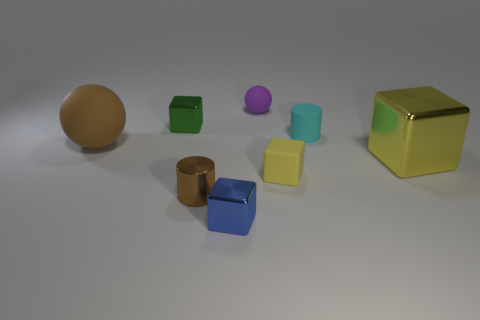Subtract all yellow metal cubes. How many cubes are left? 3 Add 2 large purple rubber blocks. How many objects exist? 10 Subtract 1 cylinders. How many cylinders are left? 1 Subtract all cyan cylinders. How many cylinders are left? 1 Subtract all spheres. How many objects are left? 6 Subtract 0 gray cylinders. How many objects are left? 8 Subtract all green cylinders. Subtract all red blocks. How many cylinders are left? 2 Subtract all gray cylinders. How many brown balls are left? 1 Subtract all small green blocks. Subtract all brown rubber spheres. How many objects are left? 6 Add 5 tiny cyan rubber things. How many tiny cyan rubber things are left? 6 